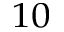<formula> <loc_0><loc_0><loc_500><loc_500>^ { 1 0 }</formula> 